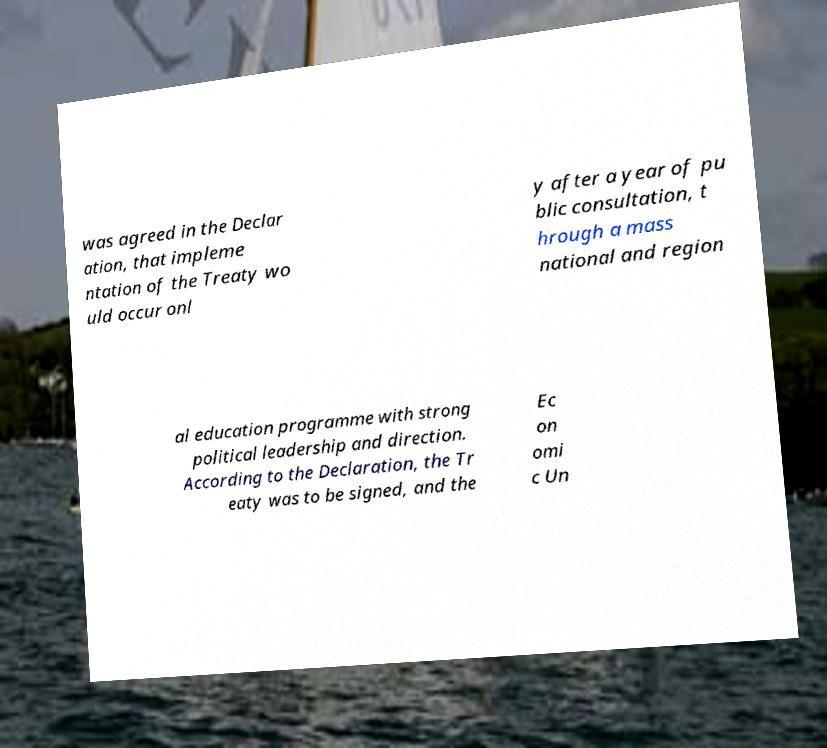There's text embedded in this image that I need extracted. Can you transcribe it verbatim? was agreed in the Declar ation, that impleme ntation of the Treaty wo uld occur onl y after a year of pu blic consultation, t hrough a mass national and region al education programme with strong political leadership and direction. According to the Declaration, the Tr eaty was to be signed, and the Ec on omi c Un 